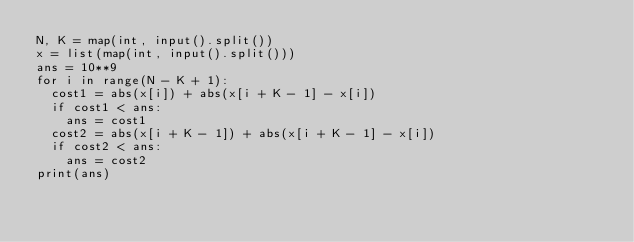<code> <loc_0><loc_0><loc_500><loc_500><_Python_>N, K = map(int, input().split())
x = list(map(int, input().split()))
ans = 10**9
for i in range(N - K + 1):
  cost1 = abs(x[i]) + abs(x[i + K - 1] - x[i])
  if cost1 < ans:
    ans = cost1
  cost2 = abs(x[i + K - 1]) + abs(x[i + K - 1] - x[i])
  if cost2 < ans:
    ans = cost2
print(ans)
</code> 